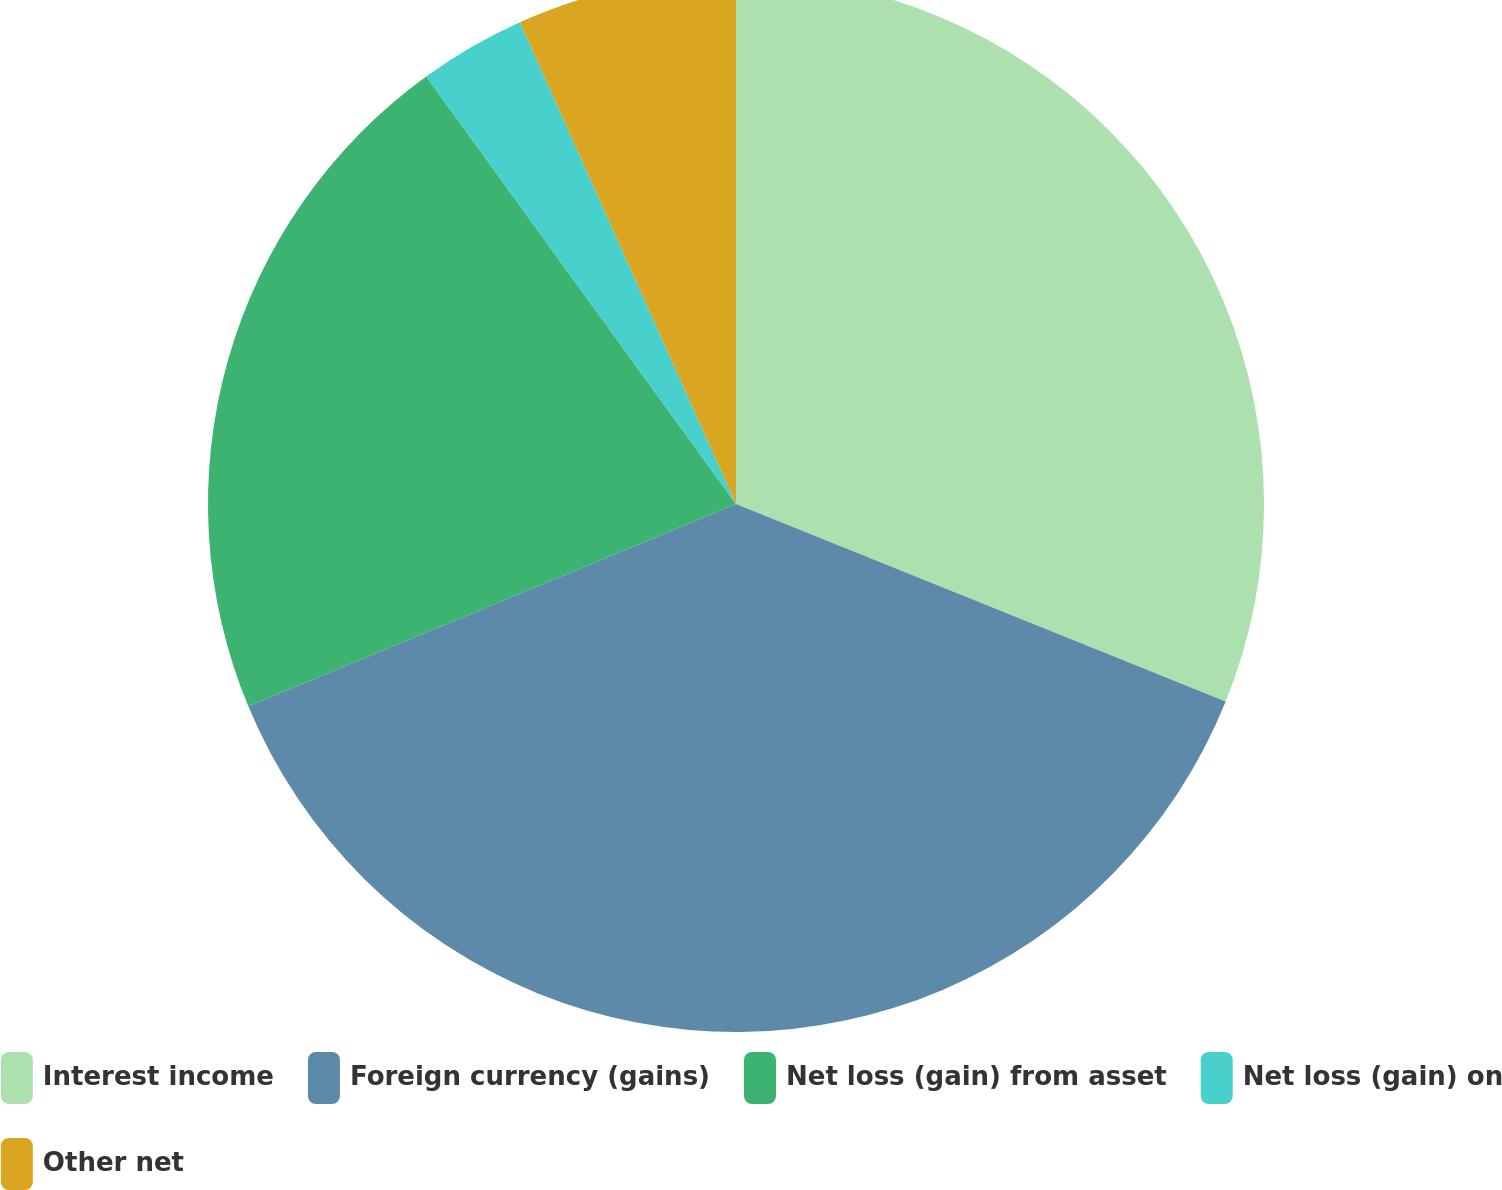<chart> <loc_0><loc_0><loc_500><loc_500><pie_chart><fcel>Interest income<fcel>Foreign currency (gains)<fcel>Net loss (gain) from asset<fcel>Net loss (gain) on<fcel>Other net<nl><fcel>31.1%<fcel>37.64%<fcel>21.28%<fcel>3.27%<fcel>6.71%<nl></chart> 